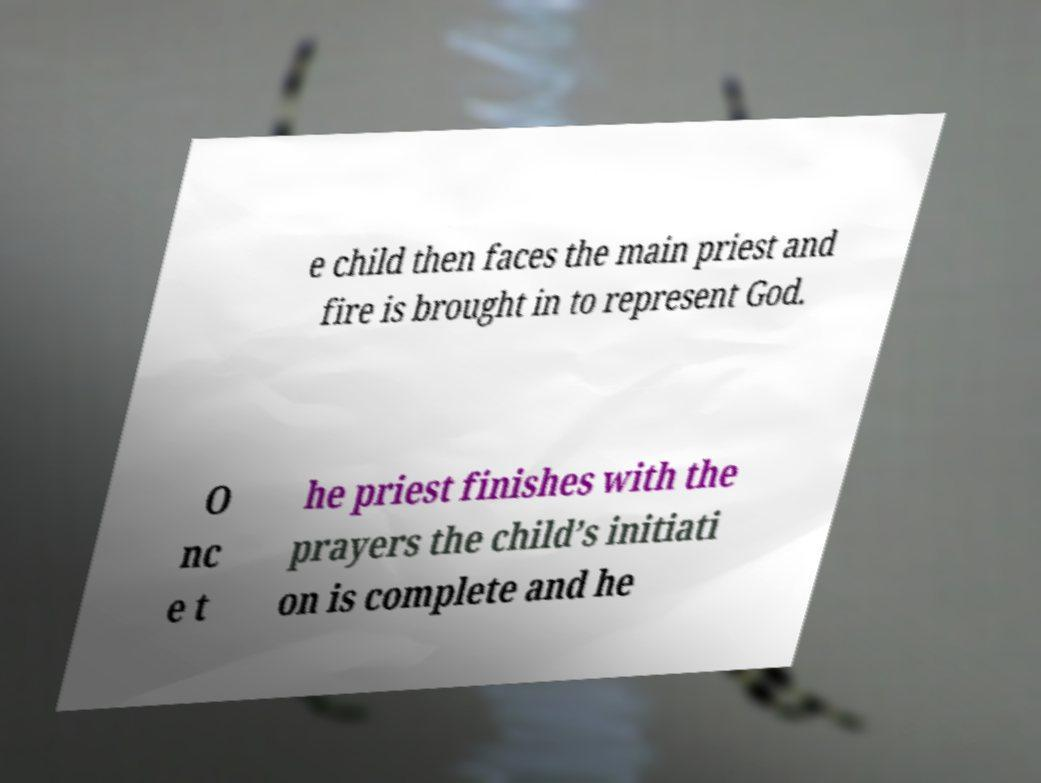Could you assist in decoding the text presented in this image and type it out clearly? e child then faces the main priest and fire is brought in to represent God. O nc e t he priest finishes with the prayers the child’s initiati on is complete and he 